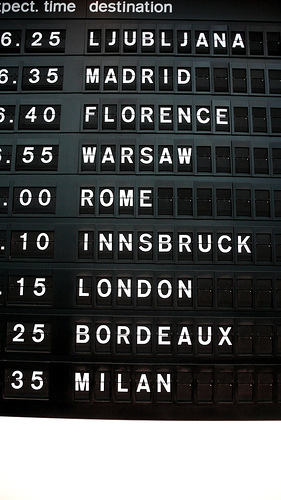<image>
Is the destination above the rome? No. The destination is not positioned above the rome. The vertical arrangement shows a different relationship. 